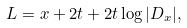<formula> <loc_0><loc_0><loc_500><loc_500>L = x + 2 t + 2 t \log | D _ { x } | ,</formula> 